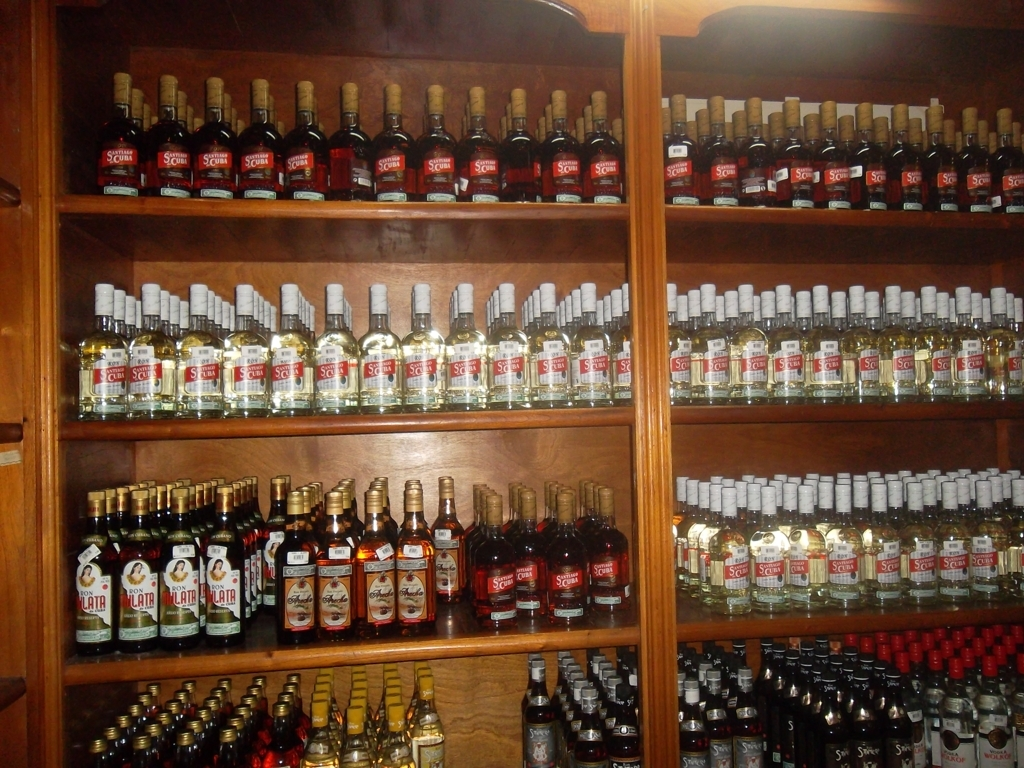Is the overall image clear? Yes, the overall image is indeed clear. It depicts an array of bottles on wooden shelves, likely in a store or cellar, with good lighting and visible labels, making it easy to discern the details. 